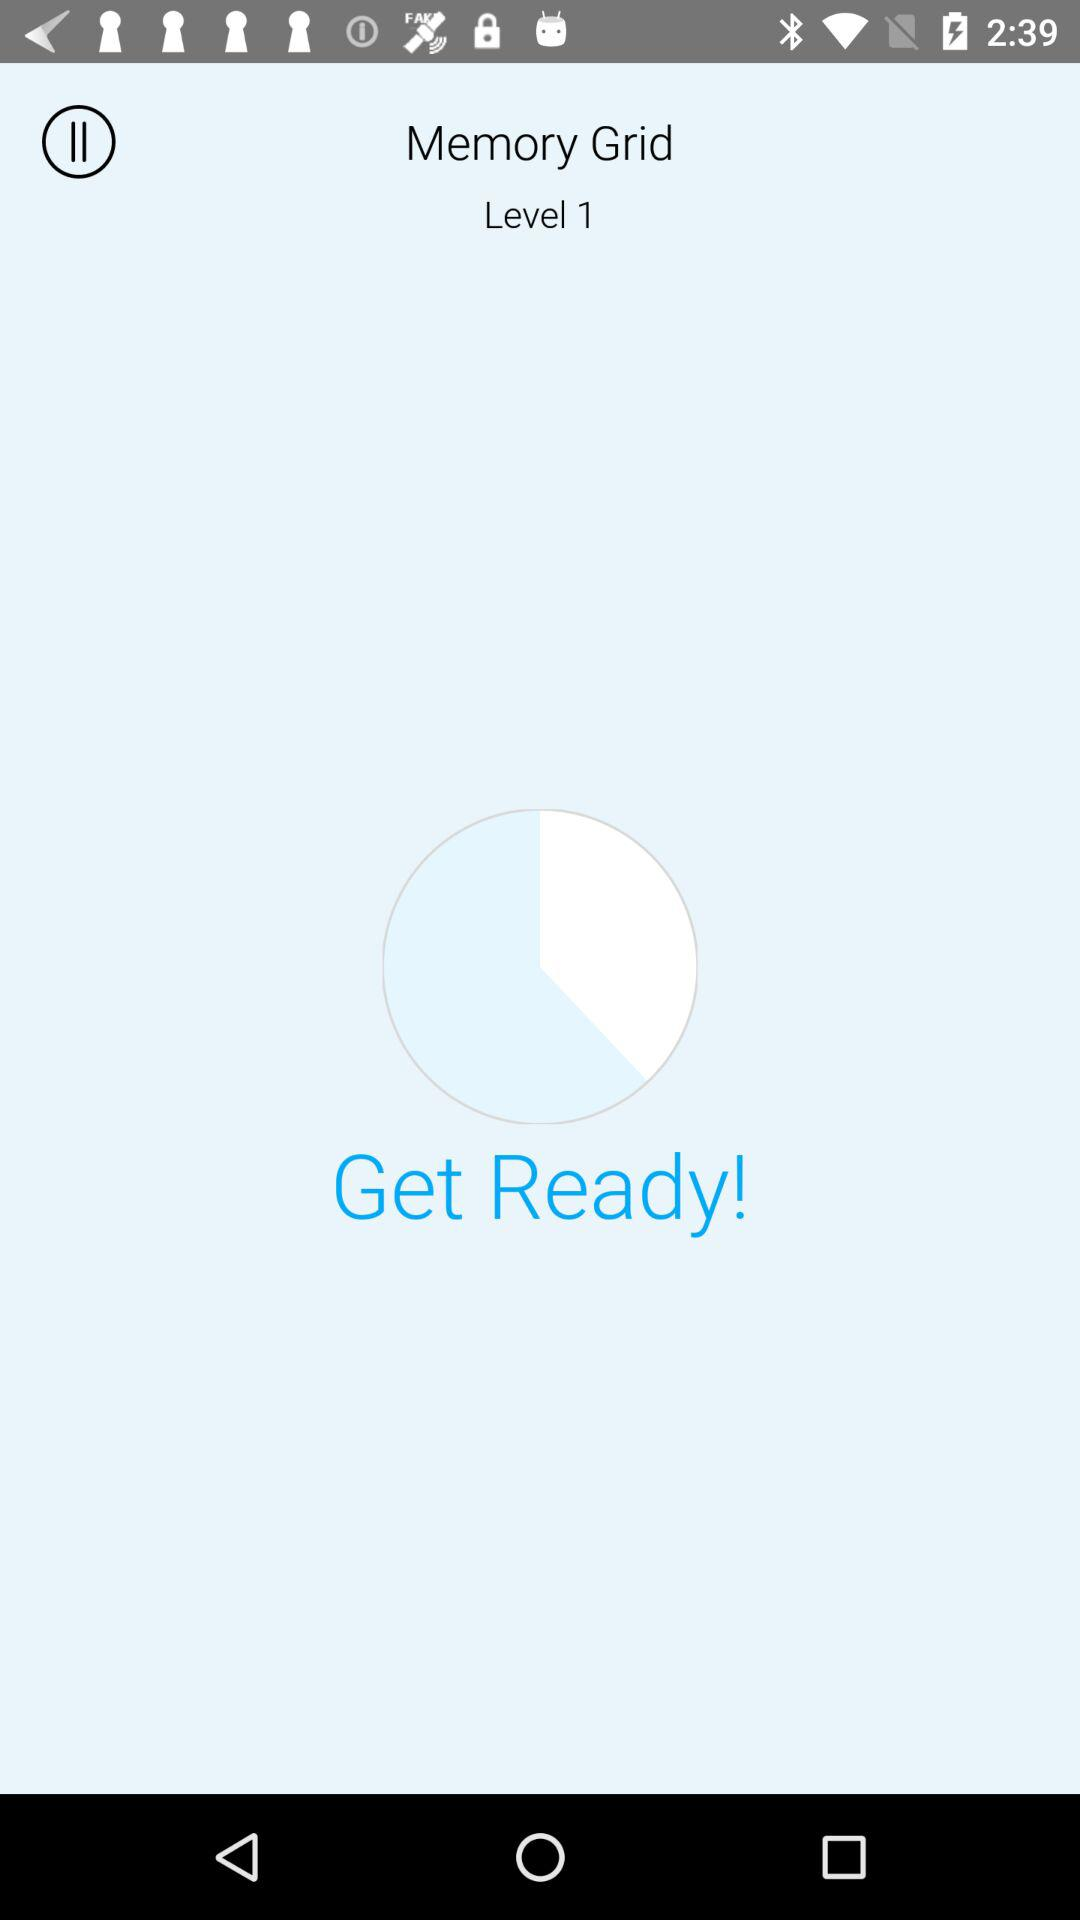What is the level? The level is 1. 